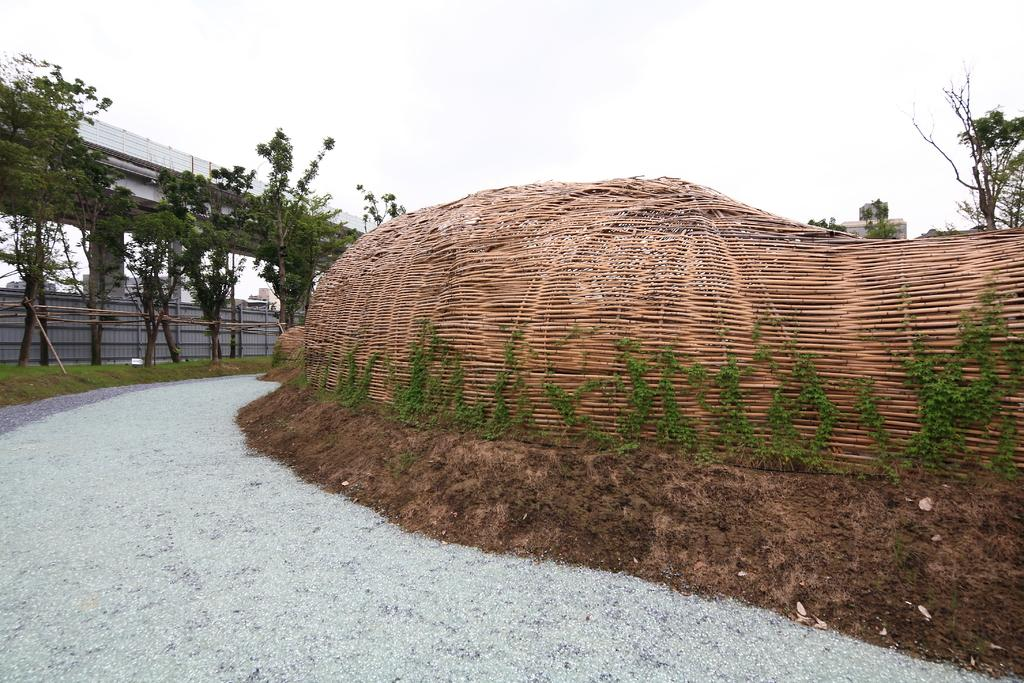What type of structure is located in the foreground of the image? There is a wooden structure in the foreground of the image. What type of vegetation is present in the image? There are trees in the image. What type of building is visible in the image? There is a shed in the image. What can be seen in the background of the image? There are buildings and the sky visible in the background of the image. Where is the notebook placed in the image? There is no notebook present in the image. What type of cart can be seen transporting goods in the image? There is no cart present in the image. 